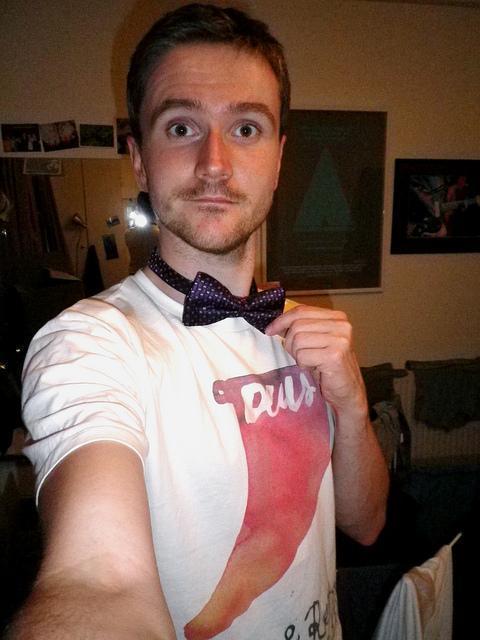How many elephants are in the picture?
Give a very brief answer. 0. 